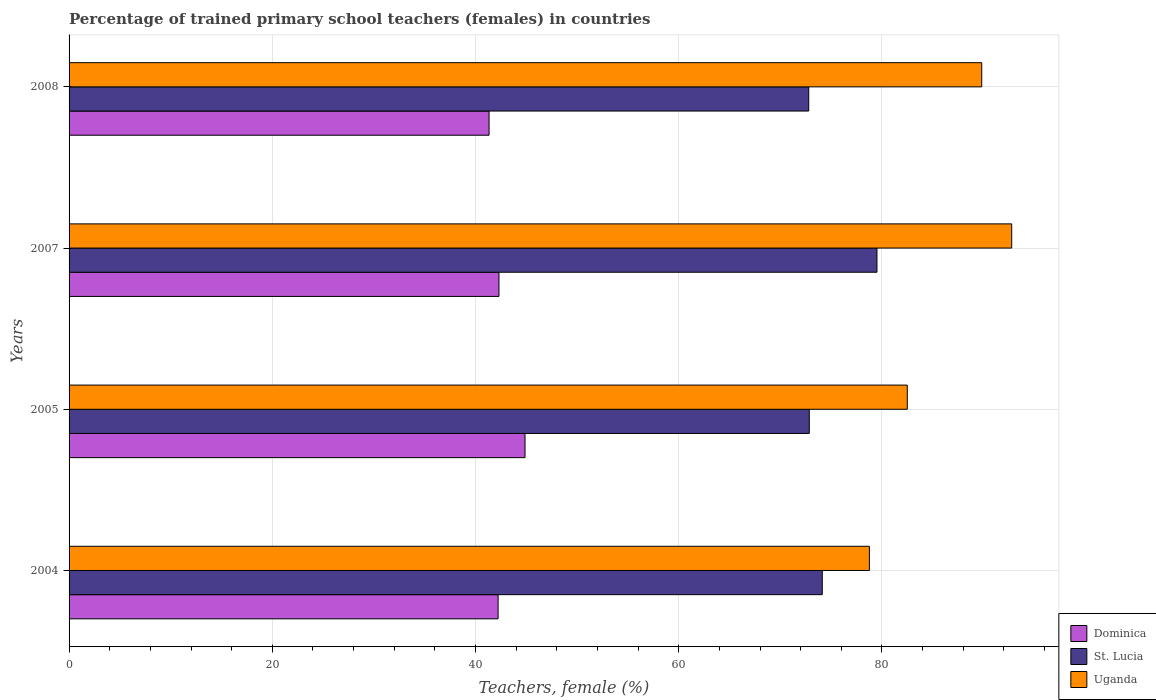How many different coloured bars are there?
Make the answer very short. 3. Are the number of bars per tick equal to the number of legend labels?
Give a very brief answer. Yes. How many bars are there on the 4th tick from the top?
Your answer should be compact. 3. In how many cases, is the number of bars for a given year not equal to the number of legend labels?
Provide a succinct answer. 0. What is the percentage of trained primary school teachers (females) in Dominica in 2008?
Offer a very short reply. 41.33. Across all years, what is the maximum percentage of trained primary school teachers (females) in St. Lucia?
Your answer should be compact. 79.51. Across all years, what is the minimum percentage of trained primary school teachers (females) in Uganda?
Your answer should be very brief. 78.76. In which year was the percentage of trained primary school teachers (females) in St. Lucia maximum?
Give a very brief answer. 2007. In which year was the percentage of trained primary school teachers (females) in Uganda minimum?
Provide a short and direct response. 2004. What is the total percentage of trained primary school teachers (females) in Uganda in the graph?
Provide a succinct answer. 343.84. What is the difference between the percentage of trained primary school teachers (females) in Dominica in 2004 and that in 2005?
Your answer should be very brief. -2.65. What is the difference between the percentage of trained primary school teachers (females) in St. Lucia in 2005 and the percentage of trained primary school teachers (females) in Dominica in 2007?
Give a very brief answer. 30.54. What is the average percentage of trained primary school teachers (females) in Uganda per year?
Provide a succinct answer. 85.96. In the year 2005, what is the difference between the percentage of trained primary school teachers (females) in Dominica and percentage of trained primary school teachers (females) in Uganda?
Make the answer very short. -37.62. What is the ratio of the percentage of trained primary school teachers (females) in Uganda in 2004 to that in 2007?
Your answer should be very brief. 0.85. Is the percentage of trained primary school teachers (females) in Dominica in 2007 less than that in 2008?
Keep it short and to the point. No. What is the difference between the highest and the second highest percentage of trained primary school teachers (females) in St. Lucia?
Offer a terse response. 5.38. What is the difference between the highest and the lowest percentage of trained primary school teachers (females) in St. Lucia?
Provide a succinct answer. 6.71. What does the 2nd bar from the top in 2004 represents?
Your answer should be very brief. St. Lucia. What does the 1st bar from the bottom in 2004 represents?
Offer a terse response. Dominica. Are all the bars in the graph horizontal?
Make the answer very short. Yes. How many years are there in the graph?
Provide a short and direct response. 4. Are the values on the major ticks of X-axis written in scientific E-notation?
Ensure brevity in your answer.  No. Does the graph contain grids?
Give a very brief answer. Yes. Where does the legend appear in the graph?
Make the answer very short. Bottom right. How many legend labels are there?
Your response must be concise. 3. How are the legend labels stacked?
Ensure brevity in your answer.  Vertical. What is the title of the graph?
Offer a terse response. Percentage of trained primary school teachers (females) in countries. What is the label or title of the X-axis?
Give a very brief answer. Teachers, female (%). What is the Teachers, female (%) in Dominica in 2004?
Give a very brief answer. 42.22. What is the Teachers, female (%) in St. Lucia in 2004?
Give a very brief answer. 74.13. What is the Teachers, female (%) of Uganda in 2004?
Ensure brevity in your answer.  78.76. What is the Teachers, female (%) in Dominica in 2005?
Your answer should be very brief. 44.87. What is the Teachers, female (%) in St. Lucia in 2005?
Your answer should be compact. 72.85. What is the Teachers, female (%) of Uganda in 2005?
Make the answer very short. 82.49. What is the Teachers, female (%) in Dominica in 2007?
Ensure brevity in your answer.  42.31. What is the Teachers, female (%) in St. Lucia in 2007?
Make the answer very short. 79.51. What is the Teachers, female (%) in Uganda in 2007?
Provide a short and direct response. 92.77. What is the Teachers, female (%) in Dominica in 2008?
Keep it short and to the point. 41.33. What is the Teachers, female (%) of St. Lucia in 2008?
Make the answer very short. 72.79. What is the Teachers, female (%) in Uganda in 2008?
Your answer should be very brief. 89.82. Across all years, what is the maximum Teachers, female (%) in Dominica?
Make the answer very short. 44.87. Across all years, what is the maximum Teachers, female (%) in St. Lucia?
Keep it short and to the point. 79.51. Across all years, what is the maximum Teachers, female (%) in Uganda?
Give a very brief answer. 92.77. Across all years, what is the minimum Teachers, female (%) in Dominica?
Your answer should be very brief. 41.33. Across all years, what is the minimum Teachers, female (%) of St. Lucia?
Your answer should be very brief. 72.79. Across all years, what is the minimum Teachers, female (%) in Uganda?
Make the answer very short. 78.76. What is the total Teachers, female (%) in Dominica in the graph?
Offer a terse response. 170.74. What is the total Teachers, female (%) in St. Lucia in the graph?
Offer a very short reply. 299.28. What is the total Teachers, female (%) of Uganda in the graph?
Your answer should be very brief. 343.84. What is the difference between the Teachers, female (%) of Dominica in 2004 and that in 2005?
Provide a short and direct response. -2.65. What is the difference between the Teachers, female (%) of St. Lucia in 2004 and that in 2005?
Your answer should be very brief. 1.28. What is the difference between the Teachers, female (%) in Uganda in 2004 and that in 2005?
Keep it short and to the point. -3.73. What is the difference between the Teachers, female (%) of Dominica in 2004 and that in 2007?
Your answer should be compact. -0.09. What is the difference between the Teachers, female (%) in St. Lucia in 2004 and that in 2007?
Ensure brevity in your answer.  -5.38. What is the difference between the Teachers, female (%) in Uganda in 2004 and that in 2007?
Provide a short and direct response. -14.01. What is the difference between the Teachers, female (%) in Dominica in 2004 and that in 2008?
Your answer should be very brief. 0.89. What is the difference between the Teachers, female (%) of St. Lucia in 2004 and that in 2008?
Make the answer very short. 1.33. What is the difference between the Teachers, female (%) in Uganda in 2004 and that in 2008?
Offer a very short reply. -11.06. What is the difference between the Teachers, female (%) in Dominica in 2005 and that in 2007?
Provide a short and direct response. 2.56. What is the difference between the Teachers, female (%) in St. Lucia in 2005 and that in 2007?
Keep it short and to the point. -6.66. What is the difference between the Teachers, female (%) in Uganda in 2005 and that in 2007?
Give a very brief answer. -10.28. What is the difference between the Teachers, female (%) of Dominica in 2005 and that in 2008?
Provide a succinct answer. 3.54. What is the difference between the Teachers, female (%) in St. Lucia in 2005 and that in 2008?
Your answer should be very brief. 0.05. What is the difference between the Teachers, female (%) in Uganda in 2005 and that in 2008?
Provide a succinct answer. -7.33. What is the difference between the Teachers, female (%) in Dominica in 2007 and that in 2008?
Offer a very short reply. 0.97. What is the difference between the Teachers, female (%) of St. Lucia in 2007 and that in 2008?
Your answer should be very brief. 6.71. What is the difference between the Teachers, female (%) in Uganda in 2007 and that in 2008?
Offer a terse response. 2.95. What is the difference between the Teachers, female (%) of Dominica in 2004 and the Teachers, female (%) of St. Lucia in 2005?
Offer a terse response. -30.63. What is the difference between the Teachers, female (%) in Dominica in 2004 and the Teachers, female (%) in Uganda in 2005?
Your response must be concise. -40.27. What is the difference between the Teachers, female (%) in St. Lucia in 2004 and the Teachers, female (%) in Uganda in 2005?
Provide a succinct answer. -8.37. What is the difference between the Teachers, female (%) in Dominica in 2004 and the Teachers, female (%) in St. Lucia in 2007?
Make the answer very short. -37.29. What is the difference between the Teachers, female (%) in Dominica in 2004 and the Teachers, female (%) in Uganda in 2007?
Keep it short and to the point. -50.55. What is the difference between the Teachers, female (%) of St. Lucia in 2004 and the Teachers, female (%) of Uganda in 2007?
Your answer should be compact. -18.64. What is the difference between the Teachers, female (%) in Dominica in 2004 and the Teachers, female (%) in St. Lucia in 2008?
Make the answer very short. -30.57. What is the difference between the Teachers, female (%) in Dominica in 2004 and the Teachers, female (%) in Uganda in 2008?
Ensure brevity in your answer.  -47.6. What is the difference between the Teachers, female (%) in St. Lucia in 2004 and the Teachers, female (%) in Uganda in 2008?
Ensure brevity in your answer.  -15.69. What is the difference between the Teachers, female (%) of Dominica in 2005 and the Teachers, female (%) of St. Lucia in 2007?
Keep it short and to the point. -34.64. What is the difference between the Teachers, female (%) of Dominica in 2005 and the Teachers, female (%) of Uganda in 2007?
Offer a very short reply. -47.9. What is the difference between the Teachers, female (%) of St. Lucia in 2005 and the Teachers, female (%) of Uganda in 2007?
Your answer should be compact. -19.92. What is the difference between the Teachers, female (%) of Dominica in 2005 and the Teachers, female (%) of St. Lucia in 2008?
Provide a succinct answer. -27.92. What is the difference between the Teachers, female (%) in Dominica in 2005 and the Teachers, female (%) in Uganda in 2008?
Provide a succinct answer. -44.95. What is the difference between the Teachers, female (%) of St. Lucia in 2005 and the Teachers, female (%) of Uganda in 2008?
Your response must be concise. -16.97. What is the difference between the Teachers, female (%) in Dominica in 2007 and the Teachers, female (%) in St. Lucia in 2008?
Give a very brief answer. -30.49. What is the difference between the Teachers, female (%) of Dominica in 2007 and the Teachers, female (%) of Uganda in 2008?
Your response must be concise. -47.51. What is the difference between the Teachers, female (%) of St. Lucia in 2007 and the Teachers, female (%) of Uganda in 2008?
Offer a very short reply. -10.31. What is the average Teachers, female (%) in Dominica per year?
Your response must be concise. 42.68. What is the average Teachers, female (%) of St. Lucia per year?
Your response must be concise. 74.82. What is the average Teachers, female (%) of Uganda per year?
Make the answer very short. 85.96. In the year 2004, what is the difference between the Teachers, female (%) in Dominica and Teachers, female (%) in St. Lucia?
Give a very brief answer. -31.9. In the year 2004, what is the difference between the Teachers, female (%) of Dominica and Teachers, female (%) of Uganda?
Provide a succinct answer. -36.54. In the year 2004, what is the difference between the Teachers, female (%) in St. Lucia and Teachers, female (%) in Uganda?
Keep it short and to the point. -4.64. In the year 2005, what is the difference between the Teachers, female (%) in Dominica and Teachers, female (%) in St. Lucia?
Your answer should be very brief. -27.98. In the year 2005, what is the difference between the Teachers, female (%) of Dominica and Teachers, female (%) of Uganda?
Give a very brief answer. -37.62. In the year 2005, what is the difference between the Teachers, female (%) of St. Lucia and Teachers, female (%) of Uganda?
Provide a succinct answer. -9.64. In the year 2007, what is the difference between the Teachers, female (%) of Dominica and Teachers, female (%) of St. Lucia?
Make the answer very short. -37.2. In the year 2007, what is the difference between the Teachers, female (%) in Dominica and Teachers, female (%) in Uganda?
Your answer should be very brief. -50.46. In the year 2007, what is the difference between the Teachers, female (%) of St. Lucia and Teachers, female (%) of Uganda?
Give a very brief answer. -13.26. In the year 2008, what is the difference between the Teachers, female (%) of Dominica and Teachers, female (%) of St. Lucia?
Offer a very short reply. -31.46. In the year 2008, what is the difference between the Teachers, female (%) of Dominica and Teachers, female (%) of Uganda?
Your answer should be compact. -48.49. In the year 2008, what is the difference between the Teachers, female (%) of St. Lucia and Teachers, female (%) of Uganda?
Your answer should be compact. -17.03. What is the ratio of the Teachers, female (%) in Dominica in 2004 to that in 2005?
Ensure brevity in your answer.  0.94. What is the ratio of the Teachers, female (%) of St. Lucia in 2004 to that in 2005?
Give a very brief answer. 1.02. What is the ratio of the Teachers, female (%) of Uganda in 2004 to that in 2005?
Provide a short and direct response. 0.95. What is the ratio of the Teachers, female (%) of St. Lucia in 2004 to that in 2007?
Offer a very short reply. 0.93. What is the ratio of the Teachers, female (%) of Uganda in 2004 to that in 2007?
Provide a succinct answer. 0.85. What is the ratio of the Teachers, female (%) in Dominica in 2004 to that in 2008?
Provide a succinct answer. 1.02. What is the ratio of the Teachers, female (%) of St. Lucia in 2004 to that in 2008?
Ensure brevity in your answer.  1.02. What is the ratio of the Teachers, female (%) in Uganda in 2004 to that in 2008?
Keep it short and to the point. 0.88. What is the ratio of the Teachers, female (%) in Dominica in 2005 to that in 2007?
Keep it short and to the point. 1.06. What is the ratio of the Teachers, female (%) in St. Lucia in 2005 to that in 2007?
Your answer should be very brief. 0.92. What is the ratio of the Teachers, female (%) in Uganda in 2005 to that in 2007?
Provide a short and direct response. 0.89. What is the ratio of the Teachers, female (%) in Dominica in 2005 to that in 2008?
Offer a terse response. 1.09. What is the ratio of the Teachers, female (%) of Uganda in 2005 to that in 2008?
Provide a short and direct response. 0.92. What is the ratio of the Teachers, female (%) of Dominica in 2007 to that in 2008?
Keep it short and to the point. 1.02. What is the ratio of the Teachers, female (%) in St. Lucia in 2007 to that in 2008?
Offer a terse response. 1.09. What is the ratio of the Teachers, female (%) in Uganda in 2007 to that in 2008?
Offer a terse response. 1.03. What is the difference between the highest and the second highest Teachers, female (%) of Dominica?
Offer a very short reply. 2.56. What is the difference between the highest and the second highest Teachers, female (%) of St. Lucia?
Your answer should be very brief. 5.38. What is the difference between the highest and the second highest Teachers, female (%) of Uganda?
Offer a terse response. 2.95. What is the difference between the highest and the lowest Teachers, female (%) of Dominica?
Keep it short and to the point. 3.54. What is the difference between the highest and the lowest Teachers, female (%) in St. Lucia?
Your answer should be very brief. 6.71. What is the difference between the highest and the lowest Teachers, female (%) of Uganda?
Ensure brevity in your answer.  14.01. 